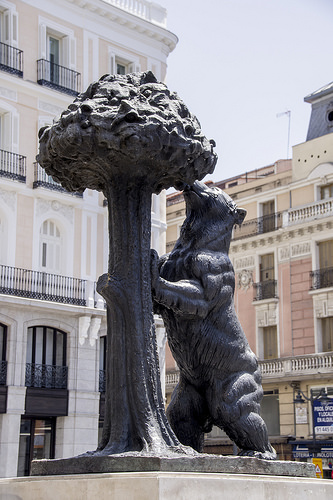<image>
Can you confirm if the statue is under the building? No. The statue is not positioned under the building. The vertical relationship between these objects is different. 